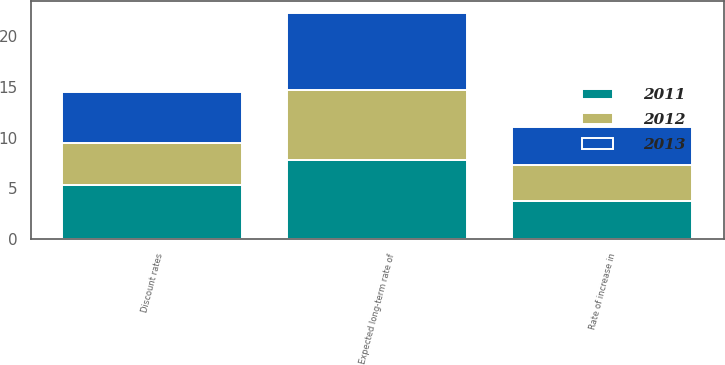Convert chart. <chart><loc_0><loc_0><loc_500><loc_500><stacked_bar_chart><ecel><fcel>Discount rates<fcel>Rate of increase in<fcel>Expected long-term rate of<nl><fcel>2012<fcel>4.22<fcel>3.58<fcel>6.94<nl><fcel>2013<fcel>4.98<fcel>3.74<fcel>7.6<nl><fcel>2011<fcel>5.3<fcel>3.75<fcel>7.79<nl></chart> 